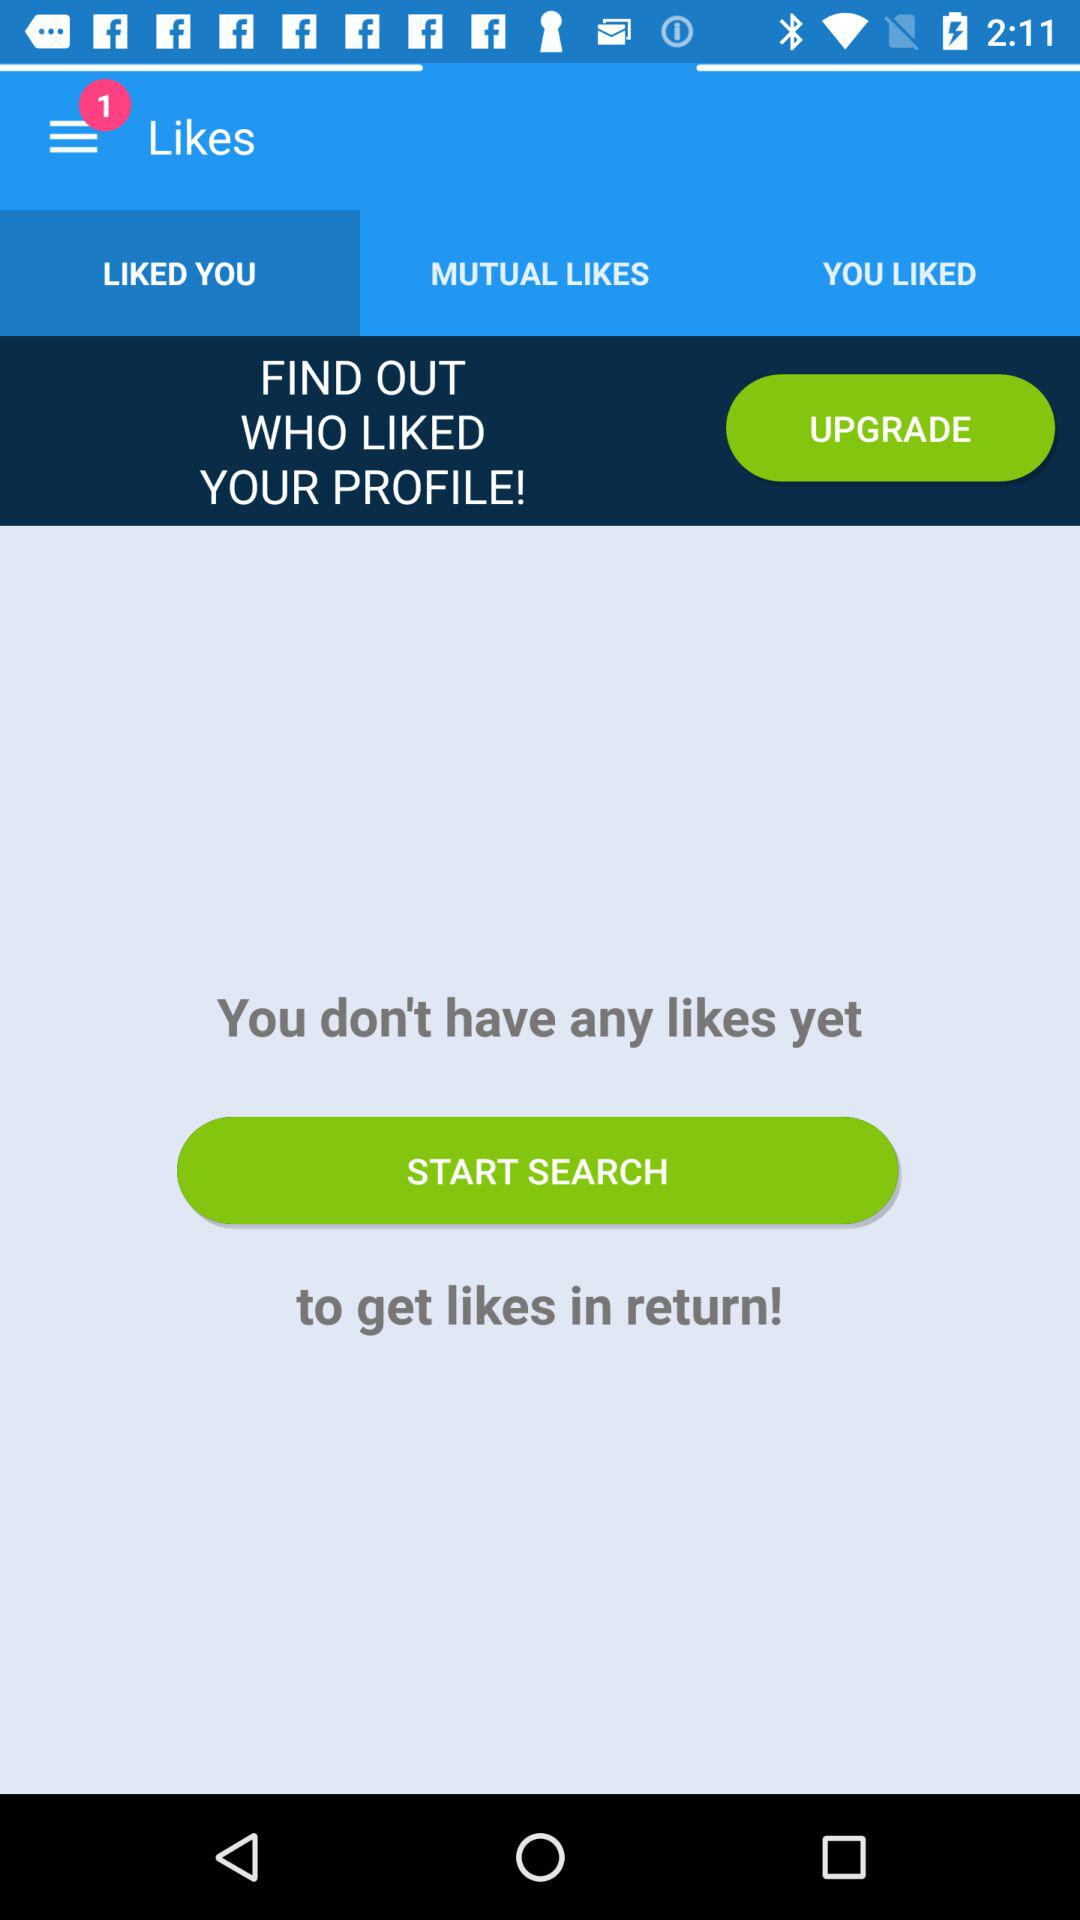How many likes are there? You don't have any likes. 